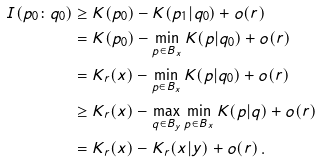Convert formula to latex. <formula><loc_0><loc_0><loc_500><loc_500>I ( p _ { 0 } \colon q _ { 0 } ) & \geq K ( p _ { 0 } ) - K ( p _ { 1 } | q _ { 0 } ) + o ( r ) \\ & = K ( p _ { 0 } ) - \min _ { p \in B _ { x } } K ( p | q _ { 0 } ) + o ( r ) \\ & = K _ { r } ( x ) - \min _ { p \in B _ { x } } K ( p | q _ { 0 } ) + o ( r ) \\ & \geq K _ { r } ( x ) - \max _ { q \in B _ { y } } \min _ { p \in B _ { x } } K ( p | q ) + o ( r ) \\ & = K _ { r } ( x ) - K _ { r } ( x | y ) + o ( r ) \, .</formula> 